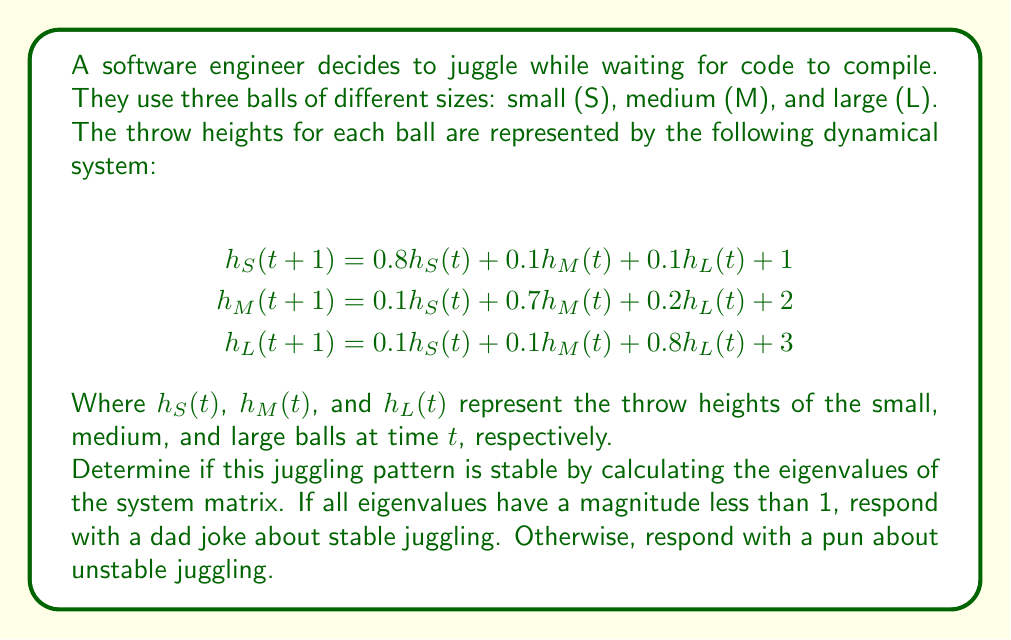Help me with this question. Let's approach this step-by-step:

1) First, we need to identify the system matrix A from the given equations:

   $$A = \begin{bmatrix}
   0.8 & 0.1 & 0.1 \\
   0.1 & 0.7 & 0.2 \\
   0.1 & 0.1 & 0.8
   \end{bmatrix}$$

2) To find the eigenvalues, we need to solve the characteristic equation:
   $$det(A - \lambda I) = 0$$

3) Expanding this determinant:
   $$\begin{vmatrix}
   0.8 - \lambda & 0.1 & 0.1 \\
   0.1 & 0.7 - \lambda & 0.2 \\
   0.1 & 0.1 & 0.8 - \lambda
   \end{vmatrix} = 0$$

4) This gives us the characteristic polynomial:
   $$-\lambda^3 + 2.3\lambda^2 - 1.73\lambda + 0.43 = 0$$

5) Solving this equation (using a computer algebra system), we get the eigenvalues:
   $$\lambda_1 \approx 1.0, \lambda_2 \approx 0.65, \lambda_3 \approx 0.65$$

6) Since one of the eigenvalues ($\lambda_1$) has a magnitude equal to 1, the system is not asymptotically stable, but it is marginally stable.

7) As per the question, since not all eigenvalues have a magnitude less than 1, we should respond with a pun about unstable juggling.
Answer: Looks like this juggling pattern is on the edge! It's a real ball-ancing act. 